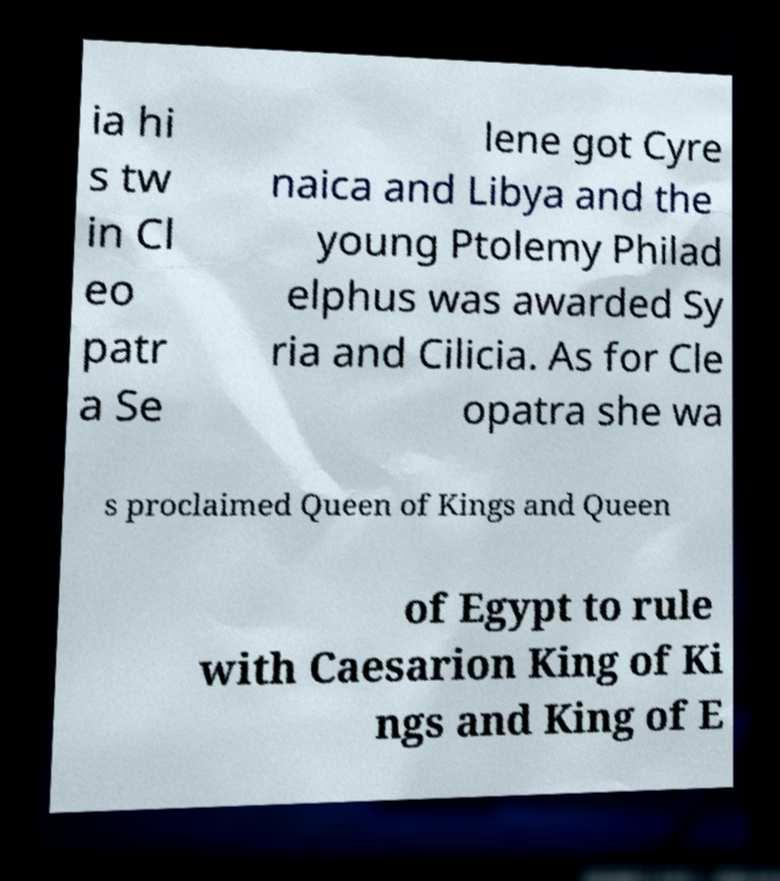Please identify and transcribe the text found in this image. ia hi s tw in Cl eo patr a Se lene got Cyre naica and Libya and the young Ptolemy Philad elphus was awarded Sy ria and Cilicia. As for Cle opatra she wa s proclaimed Queen of Kings and Queen of Egypt to rule with Caesarion King of Ki ngs and King of E 